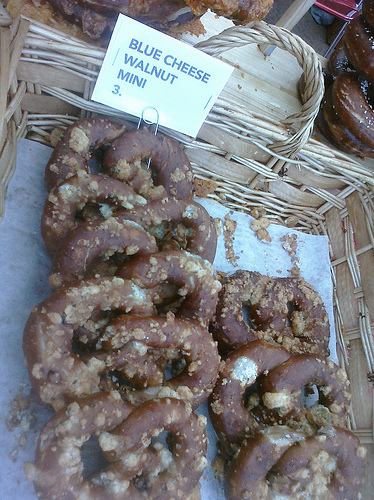<image>
Is there a label in the pretzel? Yes. The label is contained within or inside the pretzel, showing a containment relationship. 